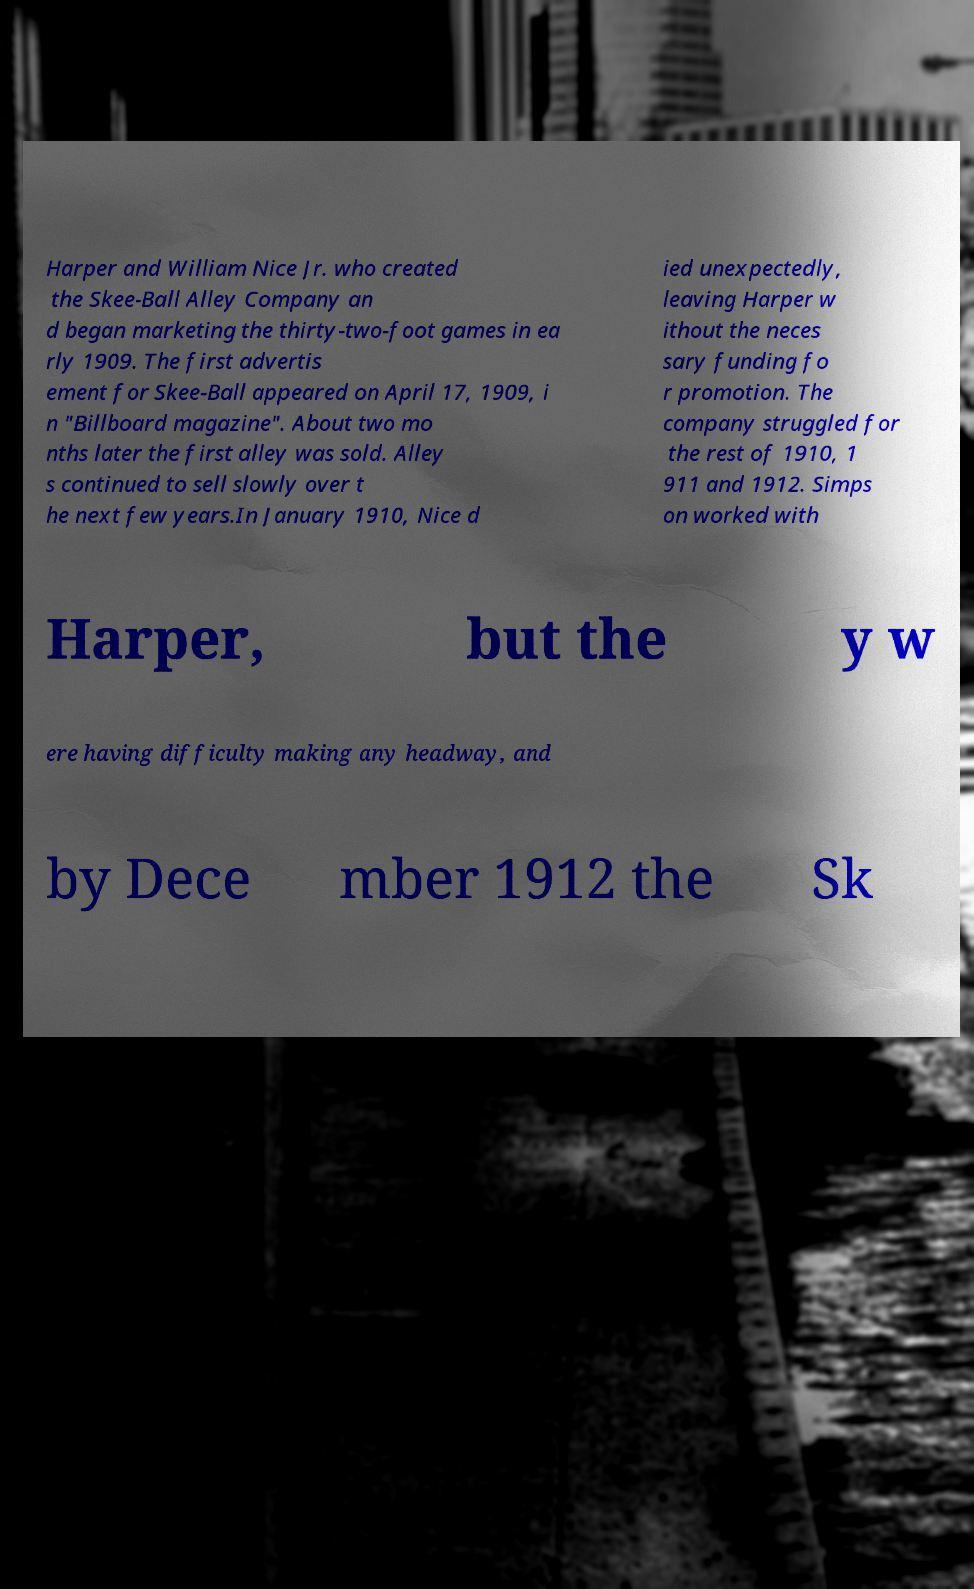Could you extract and type out the text from this image? Harper and William Nice Jr. who created the Skee-Ball Alley Company an d began marketing the thirty-two-foot games in ea rly 1909. The first advertis ement for Skee-Ball appeared on April 17, 1909, i n "Billboard magazine". About two mo nths later the first alley was sold. Alley s continued to sell slowly over t he next few years.In January 1910, Nice d ied unexpectedly, leaving Harper w ithout the neces sary funding fo r promotion. The company struggled for the rest of 1910, 1 911 and 1912. Simps on worked with Harper, but the y w ere having difficulty making any headway, and by Dece mber 1912 the Sk 